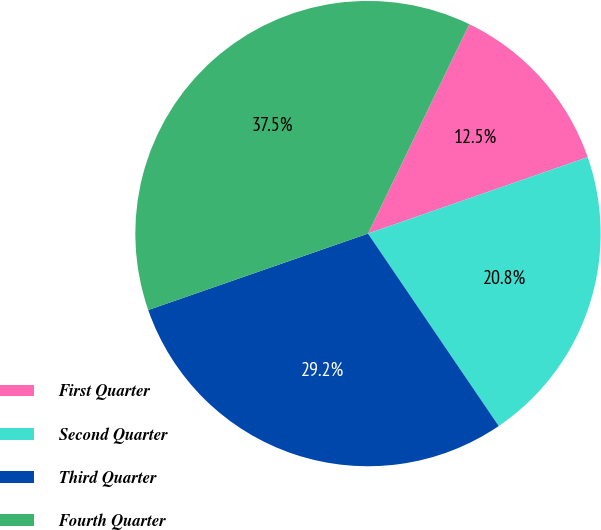Convert chart. <chart><loc_0><loc_0><loc_500><loc_500><pie_chart><fcel>First Quarter<fcel>Second Quarter<fcel>Third Quarter<fcel>Fourth Quarter<nl><fcel>12.5%<fcel>20.83%<fcel>29.17%<fcel>37.5%<nl></chart> 